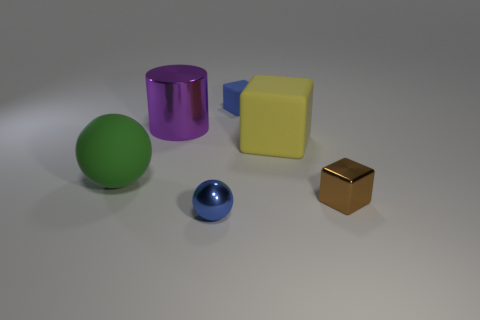What number of large green spheres are right of the yellow cube?
Make the answer very short. 0. Is the material of the block behind the purple metal object the same as the cylinder?
Offer a terse response. No. How many other things are there of the same shape as the brown thing?
Your response must be concise. 2. There is a tiny shiny object left of the small block that is in front of the blue block; how many small brown cubes are to the left of it?
Your response must be concise. 0. What color is the large object to the left of the purple cylinder?
Make the answer very short. Green. There is a big thing on the right side of the tiny metal ball; is its color the same as the tiny rubber thing?
Give a very brief answer. No. What is the size of the green thing that is the same shape as the tiny blue shiny object?
Your answer should be compact. Large. Is there any other thing that is the same size as the shiny block?
Your answer should be very brief. Yes. What is the tiny cube that is in front of the big object to the right of the blue object in front of the purple cylinder made of?
Offer a terse response. Metal. Are there more metallic balls behind the blue block than large purple shiny cylinders that are behind the purple metallic thing?
Ensure brevity in your answer.  No. 